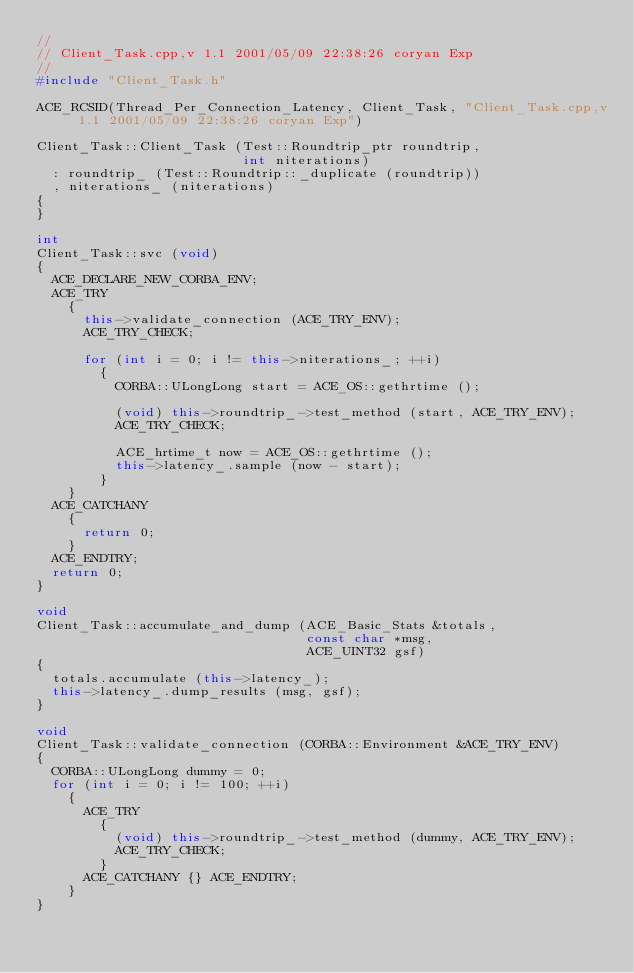Convert code to text. <code><loc_0><loc_0><loc_500><loc_500><_C++_>//
// Client_Task.cpp,v 1.1 2001/05/09 22:38:26 coryan Exp
//
#include "Client_Task.h"

ACE_RCSID(Thread_Per_Connection_Latency, Client_Task, "Client_Task.cpp,v 1.1 2001/05/09 22:38:26 coryan Exp")

Client_Task::Client_Task (Test::Roundtrip_ptr roundtrip,
                          int niterations)
  : roundtrip_ (Test::Roundtrip::_duplicate (roundtrip))
  , niterations_ (niterations)
{
}

int
Client_Task::svc (void)
{
  ACE_DECLARE_NEW_CORBA_ENV;
  ACE_TRY
    {
      this->validate_connection (ACE_TRY_ENV);
      ACE_TRY_CHECK;

      for (int i = 0; i != this->niterations_; ++i)
        {
          CORBA::ULongLong start = ACE_OS::gethrtime ();

          (void) this->roundtrip_->test_method (start, ACE_TRY_ENV);
          ACE_TRY_CHECK;

          ACE_hrtime_t now = ACE_OS::gethrtime ();
          this->latency_.sample (now - start);
        }
    }
  ACE_CATCHANY
    {
      return 0;
    }
  ACE_ENDTRY;
  return 0;
}

void
Client_Task::accumulate_and_dump (ACE_Basic_Stats &totals,
                                  const char *msg,
                                  ACE_UINT32 gsf)
{
  totals.accumulate (this->latency_);
  this->latency_.dump_results (msg, gsf);
}

void
Client_Task::validate_connection (CORBA::Environment &ACE_TRY_ENV)
{
  CORBA::ULongLong dummy = 0;
  for (int i = 0; i != 100; ++i)
    {
      ACE_TRY
        {
          (void) this->roundtrip_->test_method (dummy, ACE_TRY_ENV);
          ACE_TRY_CHECK;
        }
      ACE_CATCHANY {} ACE_ENDTRY;
    }
}
</code> 